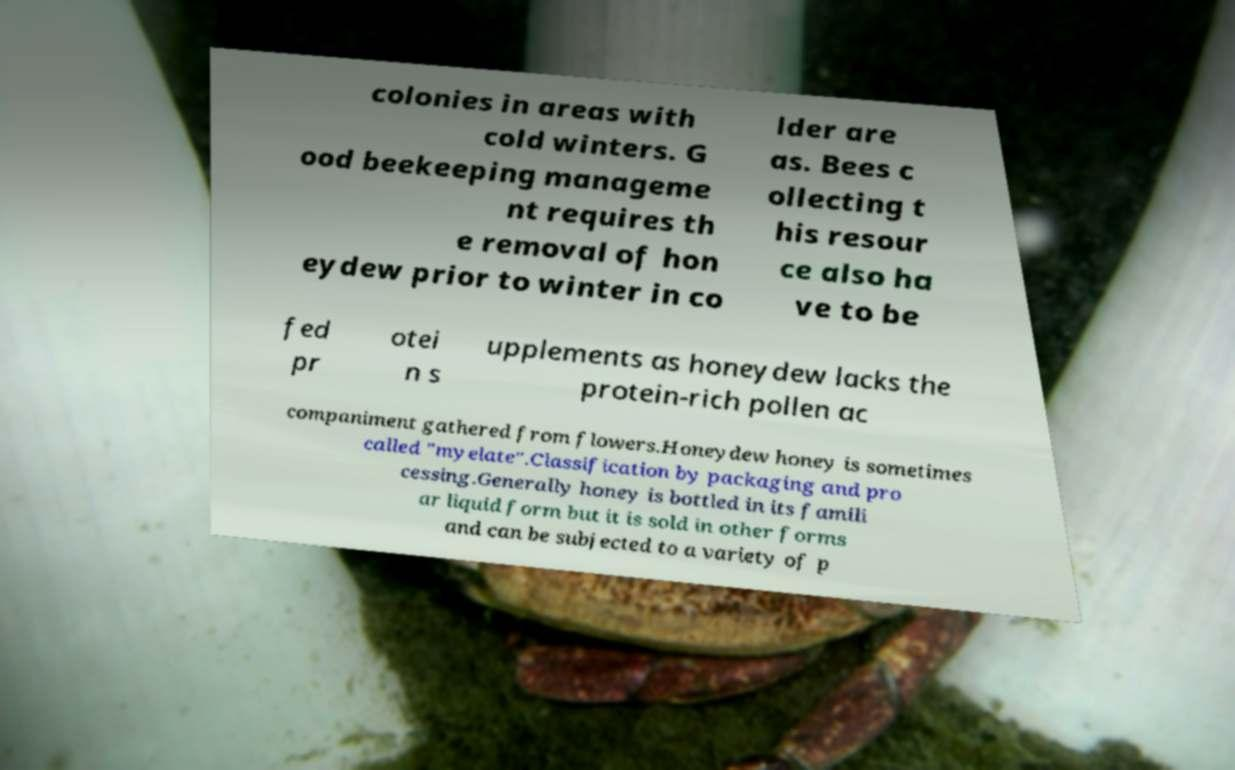Please read and relay the text visible in this image. What does it say? colonies in areas with cold winters. G ood beekeeping manageme nt requires th e removal of hon eydew prior to winter in co lder are as. Bees c ollecting t his resour ce also ha ve to be fed pr otei n s upplements as honeydew lacks the protein-rich pollen ac companiment gathered from flowers.Honeydew honey is sometimes called "myelate".Classification by packaging and pro cessing.Generally honey is bottled in its famili ar liquid form but it is sold in other forms and can be subjected to a variety of p 